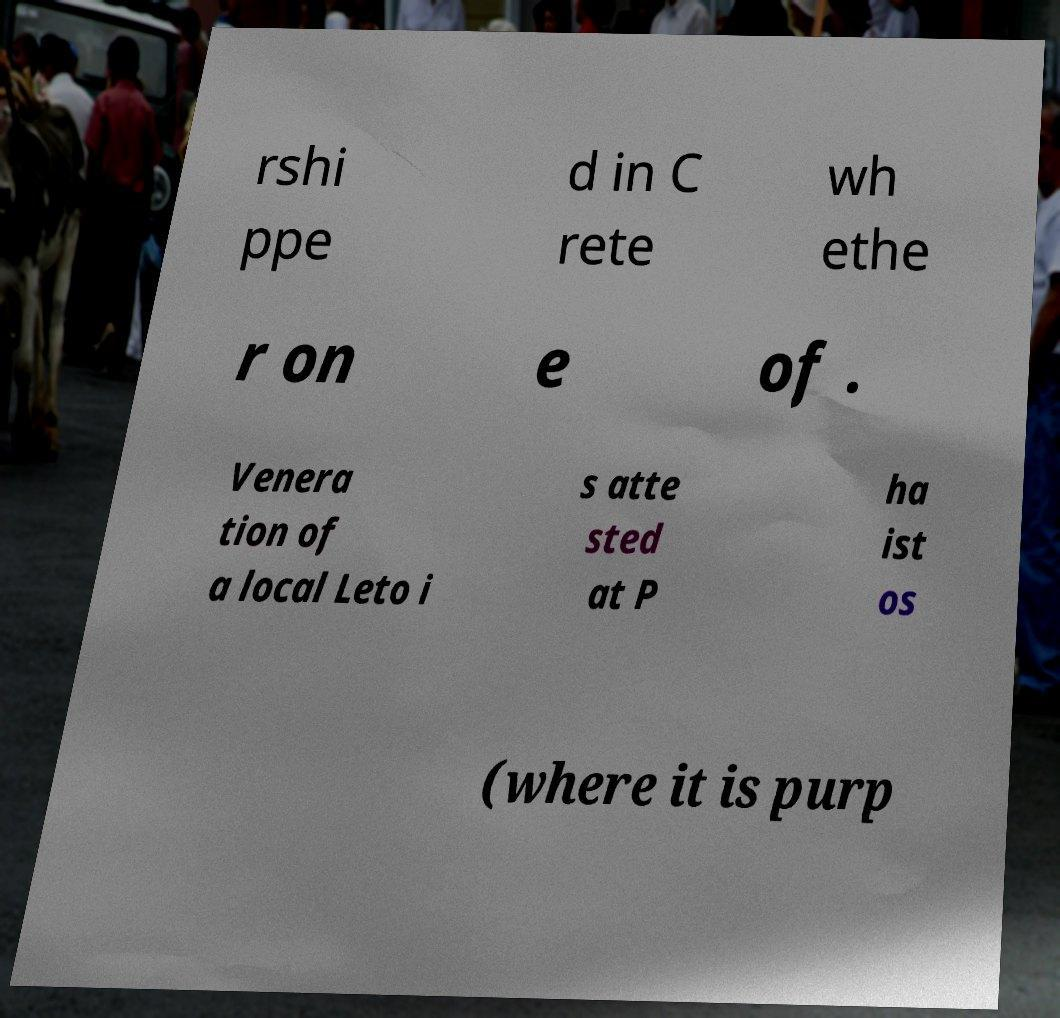Could you extract and type out the text from this image? rshi ppe d in C rete wh ethe r on e of . Venera tion of a local Leto i s atte sted at P ha ist os (where it is purp 